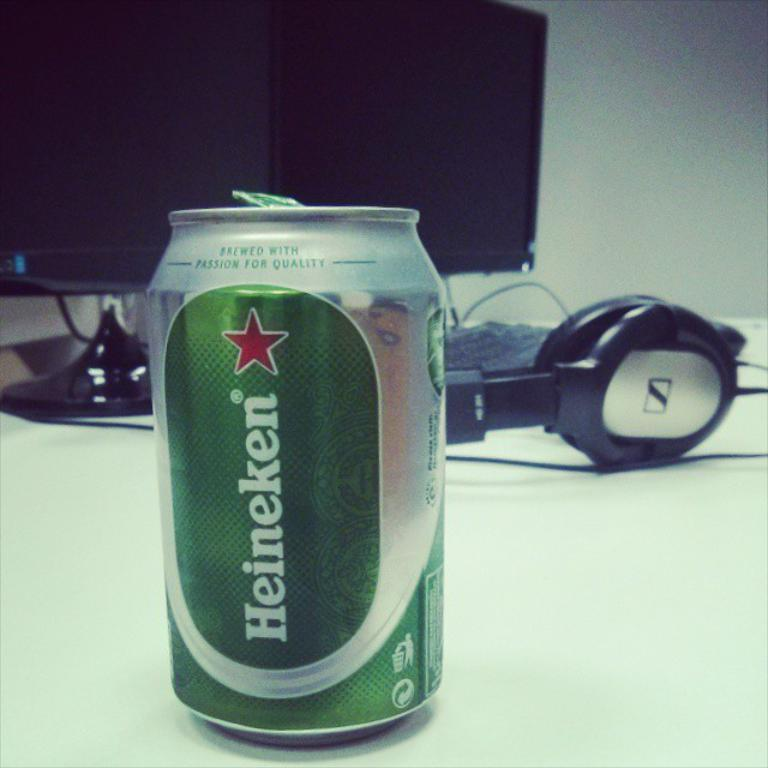<image>
Render a clear and concise summary of the photo. A can of Heineken beer sits in front of a computer and headphones. 